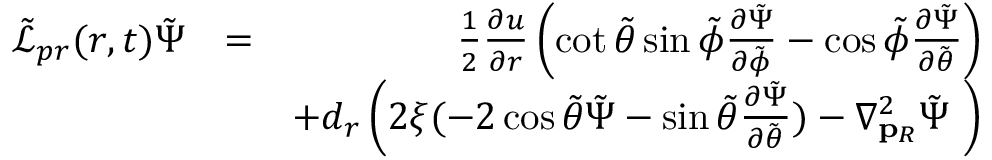Convert formula to latex. <formula><loc_0><loc_0><loc_500><loc_500>\begin{array} { r l r } { \tilde { \mathcal { L } } _ { p r } ( r , t ) \tilde { \Psi } } & { = } & { \frac { 1 } { 2 } \frac { \partial u } { \partial r } \left ( \cot { \tilde { \theta } } \sin { \tilde { \phi } } \frac { \partial \tilde { \Psi } } { \partial \tilde { \phi } } - \cos { \tilde { \phi } } \frac { \partial \tilde { \Psi } } { \partial \tilde { \theta } } \right ) } \\ & { + d _ { r } \left ( 2 \xi ( - 2 \cos { \tilde { \theta } } \tilde { \Psi } - \sin { \tilde { \theta } } \frac { \partial \tilde { \Psi } } { \partial \tilde { \theta } } ) - \nabla _ { p _ { R } } ^ { 2 } \tilde { \Psi } \ \right ) } \end{array}</formula> 